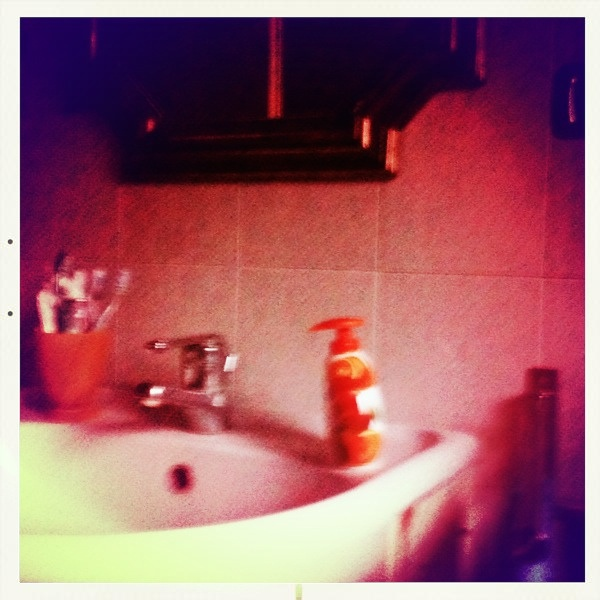Describe the objects in this image and their specific colors. I can see sink in ivory, khaki, beige, lightpink, and salmon tones, cup in ivory and brown tones, toothbrush in ivory, salmon, and brown tones, toothbrush in ivory, brown, and purple tones, and toothbrush in ivory, salmon, and brown tones in this image. 